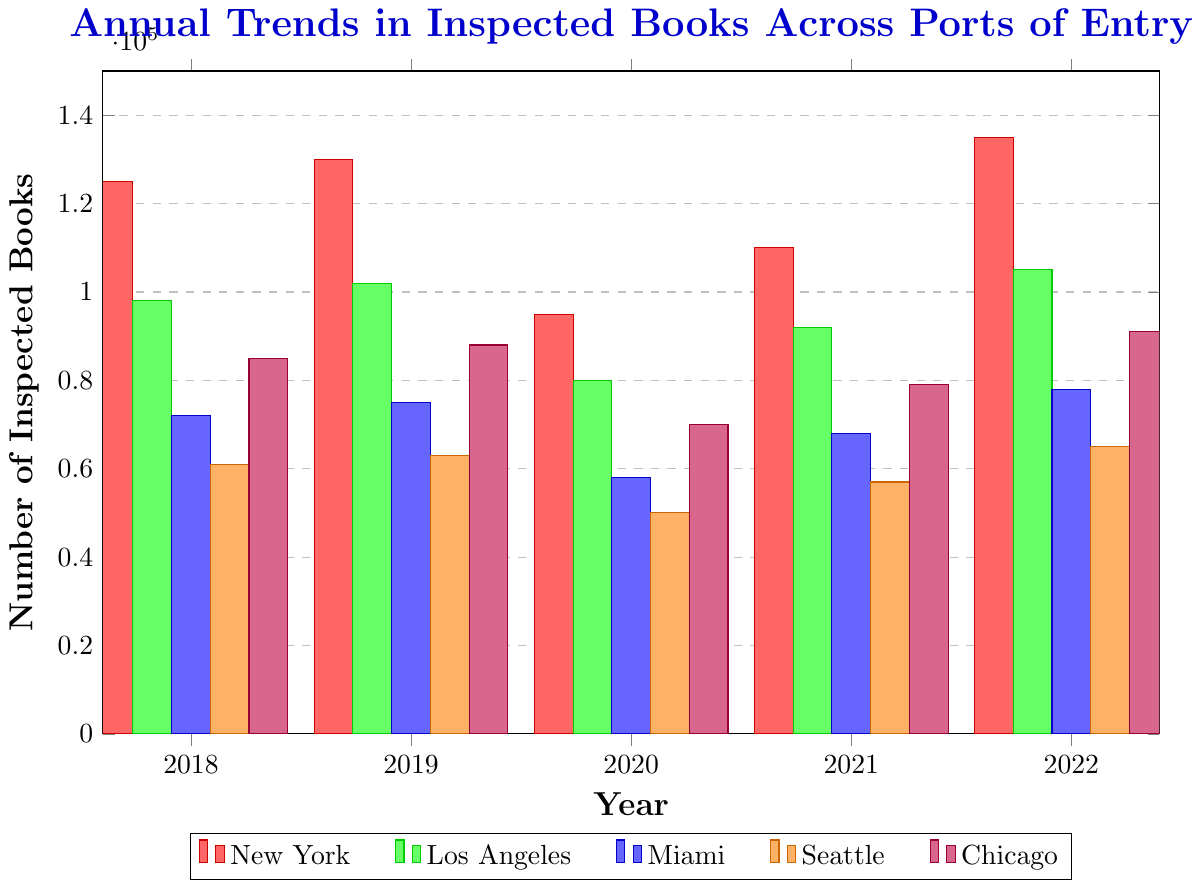What is the total number of inspected books in 2018 across all ports? The number of inspected books in 2018 for each port is: New York=125000, Los Angeles=98000, Miami=72000, Seattle=61000, Chicago=85000. Adding them up gives 125000 + 98000 + 72000 + 61000 + 85000 = 441000
Answer: 441000 Which port had the highest number of inspected books in 2022? In 2022, the number of inspected books for each port is: New York=135000, Los Angeles=105000, Miami=78000, Seattle=65000, Chicago=91000. Among these, New York has the highest number.
Answer: New York How did the number of inspected books in 2020 compare between New York and Los Angeles? In 2020, the number of inspected books for New York is 95000 and for Los Angeles is 80000. Comparing these, New York had more inspected books than Los Angeles.
Answer: New York Which port had the least number of inspected books across all years shown? The least number of inspected books across all years for each port are: New York=95000, Los Angeles=80000, Miami=58000, Seattle=50000, Chicago=70000. Among these, Seattle in 2020 had the least with 50000 books.
Answer: Seattle What is the average number of inspected books over the five years for Chicago? The number of inspected books for Chicago over the five years is: 85000, 88000, 70000, 79000, 91000. Summing them up gives 85000 + 88000 + 70000 + 79000 + 91000 = 413000. Dividing by 5 gives 413000/5 = 82600
Answer: 82600 Which year had the highest total number of inspected books across all ports? The total number of inspected books for each year is: 2018=441000, 2019=458000, 2020=353000, 2021=406000, 2022=474000. Among these, 2022 had the highest total number with 474000 books.
Answer: 2022 How did the number of inspected books in 2022 for Seattle compare to 2021 for the same port? In 2022, Seattle had 65000 inspected books. In 2021, it had 57000. Comparing these, 2022 had more inspected books for Seattle than 2021.
Answer: 2022 Which port experienced the most significant decrease in the number of inspected books from 2019 to 2020? The decrease in the number of inspected books from 2019 to 2020 for each port is: New York=130000-95000=35000, Los Angeles=102000-80000=22000, Miami=75000-58000=17000, Seattle=63000-50000=13000, Chicago=88000-70000=18000. New York experienced the most significant decrease with 35000 books.
Answer: New York How does the bar height for Miami in 2020 compare visually to that of Seattle in 2022? The bar height for Miami in 2020 (58000) is visually shorter than that of Seattle in 2022 (65000).
Answer: Shorter What is the difference in the number of inspected books between Miami and Chicago in 2021? In 2021, Miami had 68000 inspected books and Chicago had 79000. The difference is 79000 - 68000 = 11000
Answer: 11000 